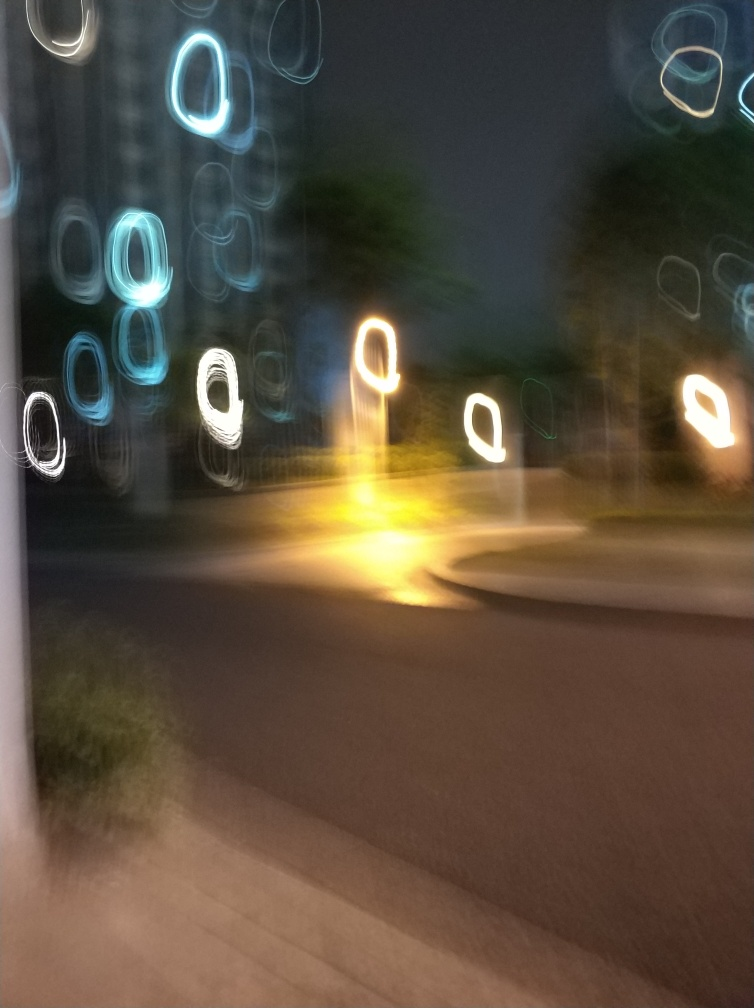What time of day does this image seem to capture? The image appears to capture a scene during the evening or night, as evidenced by the artificial lighting and the overall dark environment. What mood does this image evoke? The image evokes a sense of motion and dynamics, possible haste, or the rhythm of urban life at night. The play of light and shadow creates an atmosphere that might be described as energetic, if not a bit chaotic. 